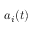<formula> <loc_0><loc_0><loc_500><loc_500>a _ { i } ( t )</formula> 